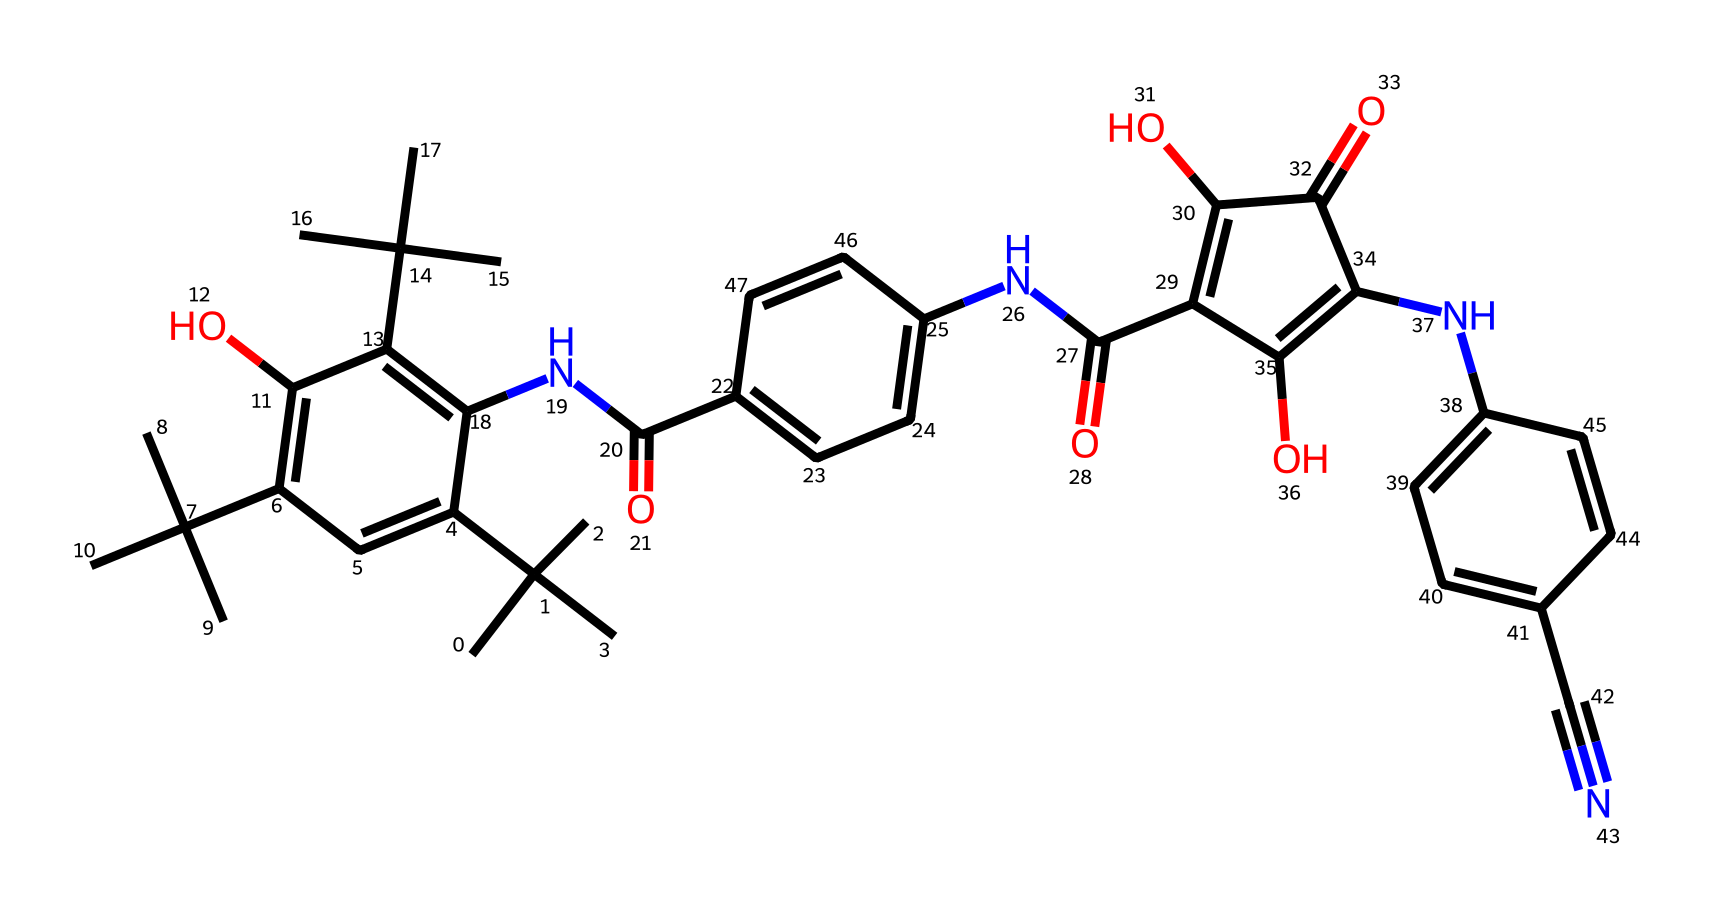what is the total number of carbon atoms in this chemical structure? By analyzing the SMILES representation, you can count the number of carbon ('C') symbols. There are 24 carbon atoms indicated in the structure.
Answer: 24 how many nitrogen atoms are present in the structure? In the given SMILES, the occurrences of 'N' represent nitrogen atoms. By counting them, we find there are 4 nitrogen atoms present.
Answer: 4 what is the molecular weight of this chemical compound? To find the molecular weight, one must add the weights of each atom based on the count observed in the structure: Carbon (12.01 g/mol), Hydrogen (1.008 g/mol), Oxygen (16.00 g/mol), and Nitrogen (14.01 g/mol). Calculating using the counts gives a total of approximately 386.43 g/mol.
Answer: approximately 386.43 which functional group is present that may contribute to solubility? The presence of hydroxyl groups ('-OH') suggests the chemical can engage in hydrogen bonding, which typically enhances solubility in polar solvents. The identical patterns in the structure signify multiple -OH groups.
Answer: hydroxyl how many rings are in this chemical structure? By inspecting the structure highlighted by the 'c' symbols (indicating aromatic carbon), and recognizing those that form closed loops leads to the identification of 3 distinct aromatic rings.
Answer: 3 what does the presence of the cyano group ('-C#N') suggest about its chemical properties? The cyano group consists of a carbon triple-bonded to a nitrogen atom. This configuration indicates the compound has properties associated with nitriles, such as potential acidity and electrophilicity.
Answer: potential acidity what type of bonds are primarily present in this compound? The structure contains primarily single and double bonds, with the notable presence of one triple bond (the cyano group). The single and double bonds dominate the overall structure.
Answer: single and double bonds 